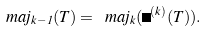<formula> <loc_0><loc_0><loc_500><loc_500>\ m a j _ { k - 1 } ( T ) = \ m a j _ { k } ( \Phi ^ { ( k ) } ( T ) ) .</formula> 